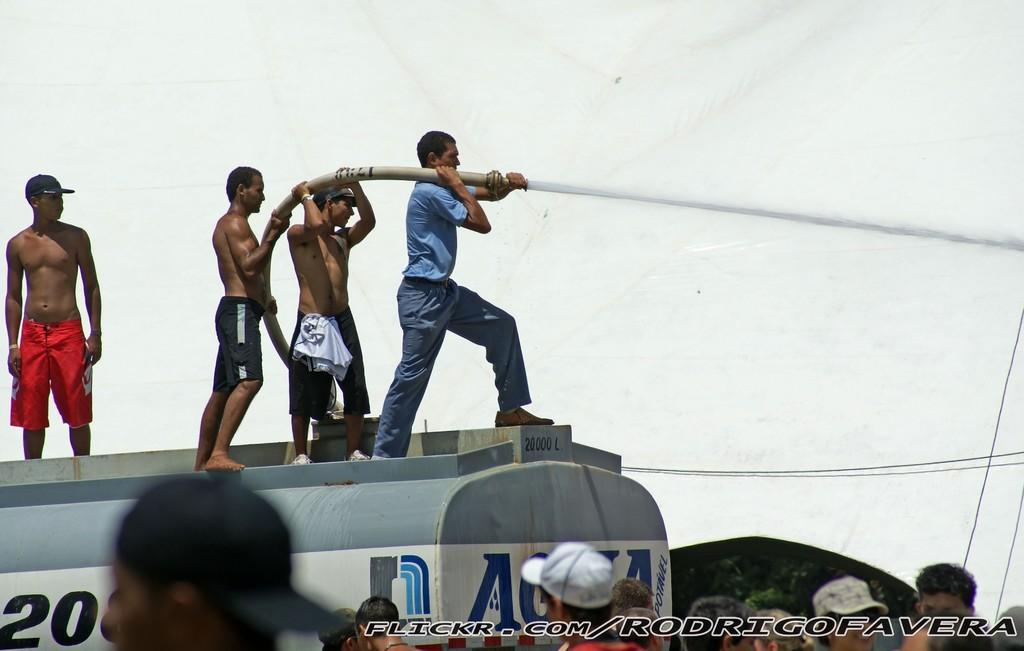What is the main subject of the image? The main subject of the image is people standing on a tank. What are the people on the tank holding? The people on the tank are holding pipes. What is happening below the tank in the image? There are people standing below the tank in the image. What can be observed about the clothing of some of the people below the tank? Some of the people below the tank are wearing caps. What type of bears can be seen in the cave in the image? There are no bears or caves present in the image. 